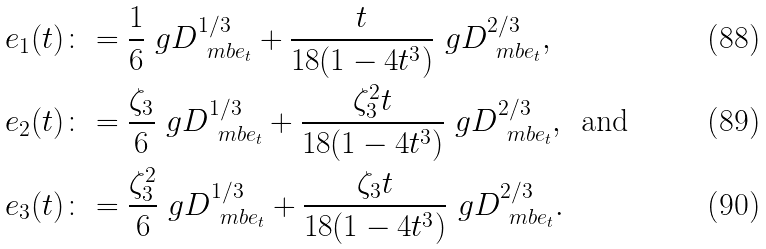Convert formula to latex. <formula><loc_0><loc_0><loc_500><loc_500>e _ { 1 } ( t ) & \colon = \frac { 1 } { 6 } \ g D _ { \ m b e _ { t } } ^ { 1 / 3 } + \frac { t } { 1 8 ( 1 - 4 t ^ { 3 } ) } \ g D _ { \ m b e _ { t } } ^ { 2 / 3 } , \\ e _ { 2 } ( t ) & \colon = \frac { \zeta _ { 3 } } { 6 } \ g D _ { \ m b e _ { t } } ^ { 1 / 3 } + \frac { \zeta _ { 3 } ^ { 2 } t } { 1 8 ( 1 - 4 t ^ { 3 } ) } \ g D _ { \ m b e _ { t } } ^ { 2 / 3 } , \, \text { and} \\ e _ { 3 } ( t ) & \colon = \frac { \zeta _ { 3 } ^ { 2 } } { 6 } \ g D _ { \ m b e _ { t } } ^ { 1 / 3 } + \frac { \zeta _ { 3 } t } { 1 8 ( 1 - 4 t ^ { 3 } ) } \ g D _ { \ m b e _ { t } } ^ { 2 / 3 } .</formula> 